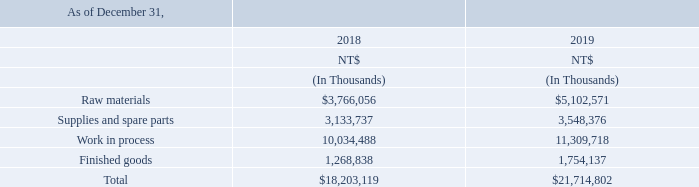A. for the years ended december 31, 2017, 2018 and 2019, the company recognized nt$118,252 million, nt$123,795 million and nt$122,999 million, respectively, in operating costs, of which nt$2,256 million, nt$1,698 million and nt$820 million in 2017, 2018 and 2019, respectively, were related to write-down of inventories.
b. none of the aforementioned inventories were pledged.
what were the operating costs for the year ended december 31, 2017? Nt$118,252 million. How much of operating costs were related to write-down of inventories for year ended December 31, 2017? Nt$2,256 million. How many inventories were pledged? None. What was the increase / (decrease) in the raw materials from 2018 to 2019?
Answer scale should be: million. 5,102,571 - 3,766,056
Answer: 1336515. What was the average Supplies and spare parts?
Answer scale should be: million. (3,133,737 + 3,548,376) / 2
Answer: 3341056.5. What was the percentage increase / (decrease) in the Finished goods from 2018 to 2019?
Answer scale should be: percent. 1,754,137 / 1,268,838 - 1
Answer: 38.25. 